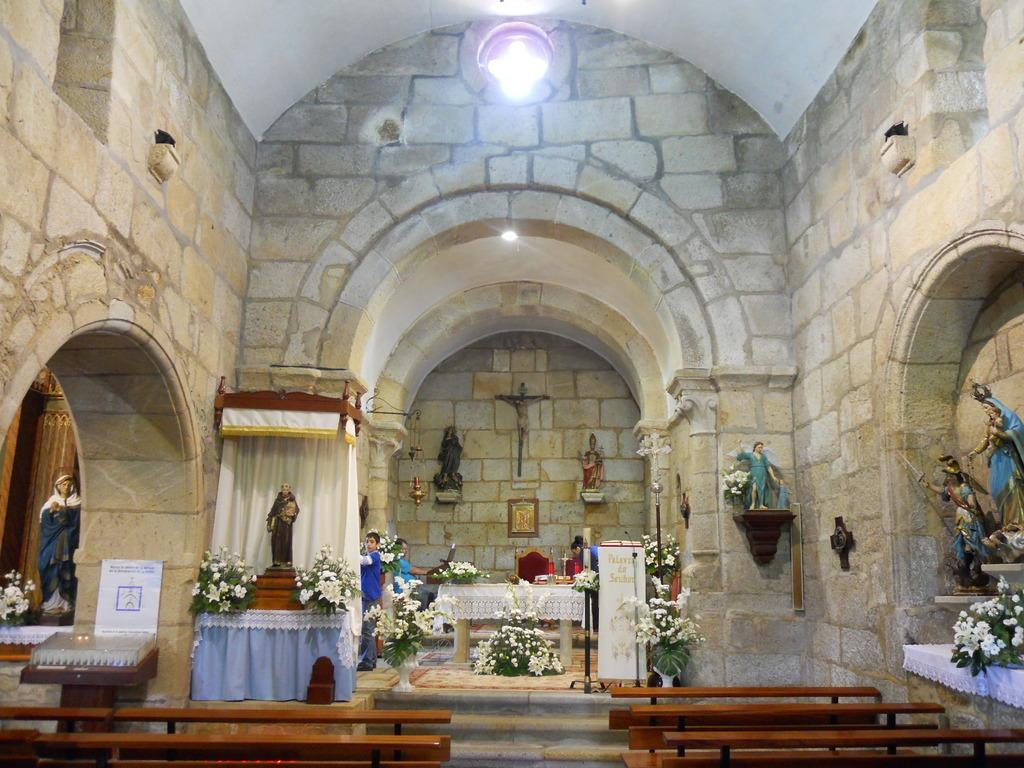Where is the image taken? The image is captured inside a church. What can be seen inside the church? There are many sculptures and flower plants in the image. What is the seating arrangement like in the church? There are empty benches in the image. What type of ship can be seen sailing in the background of the image? There is no ship present in the image; it is taken inside a church. 